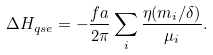Convert formula to latex. <formula><loc_0><loc_0><loc_500><loc_500>\Delta H _ { q s e } = - \frac { f a } { 2 \pi } \sum _ { i } \frac { \eta ( m _ { i } / \delta ) } { \mu _ { i } } .</formula> 